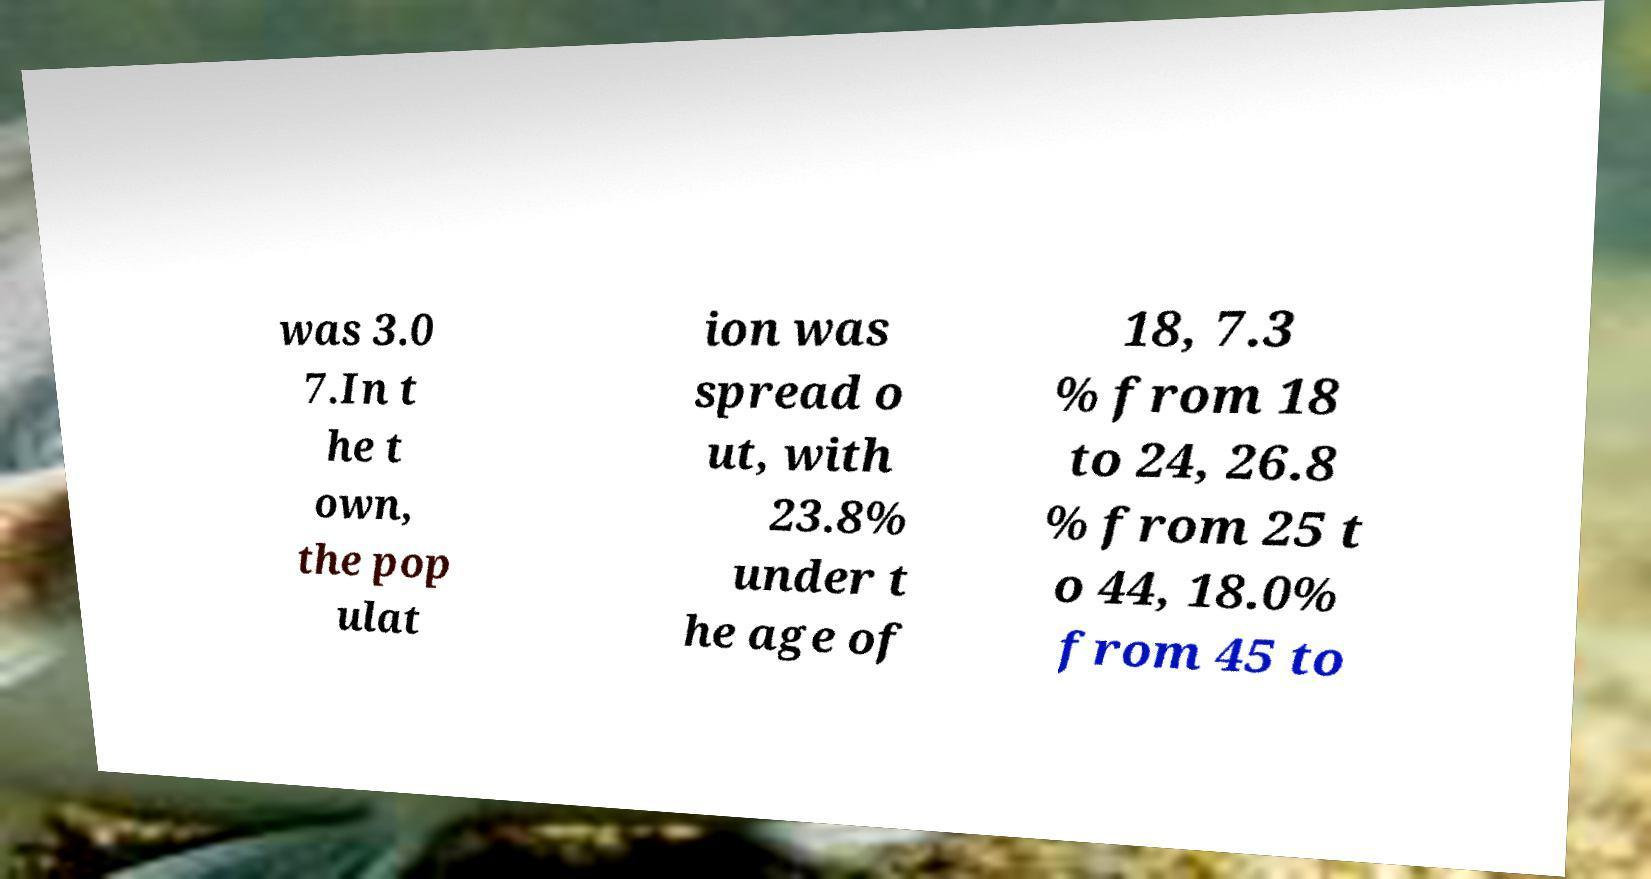Please identify and transcribe the text found in this image. was 3.0 7.In t he t own, the pop ulat ion was spread o ut, with 23.8% under t he age of 18, 7.3 % from 18 to 24, 26.8 % from 25 t o 44, 18.0% from 45 to 